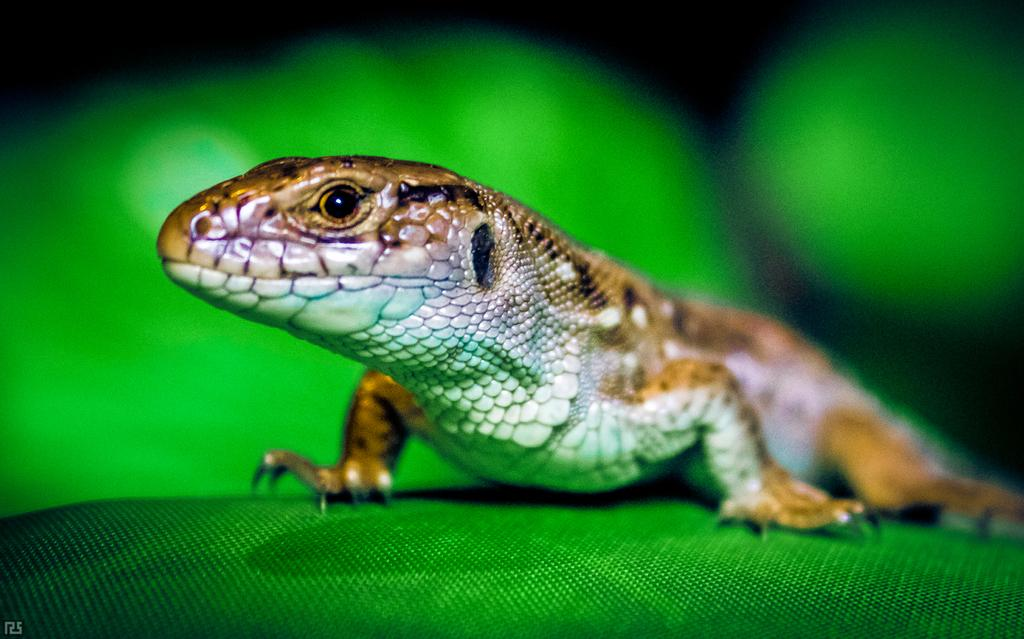What type of animal is in the image? There is a lizard in the image. What is the lizard resting on in the image? The lizard is on a green surface. What color is the background of the image? The background of the image is green in color. What type of farm animals can be seen in the image? There are no farm animals present in the image; it features a lizard on a green surface with a green background. How many lines are visible in the image? There are no lines visible in the image; it features a lizard on a green surface with a green background. 